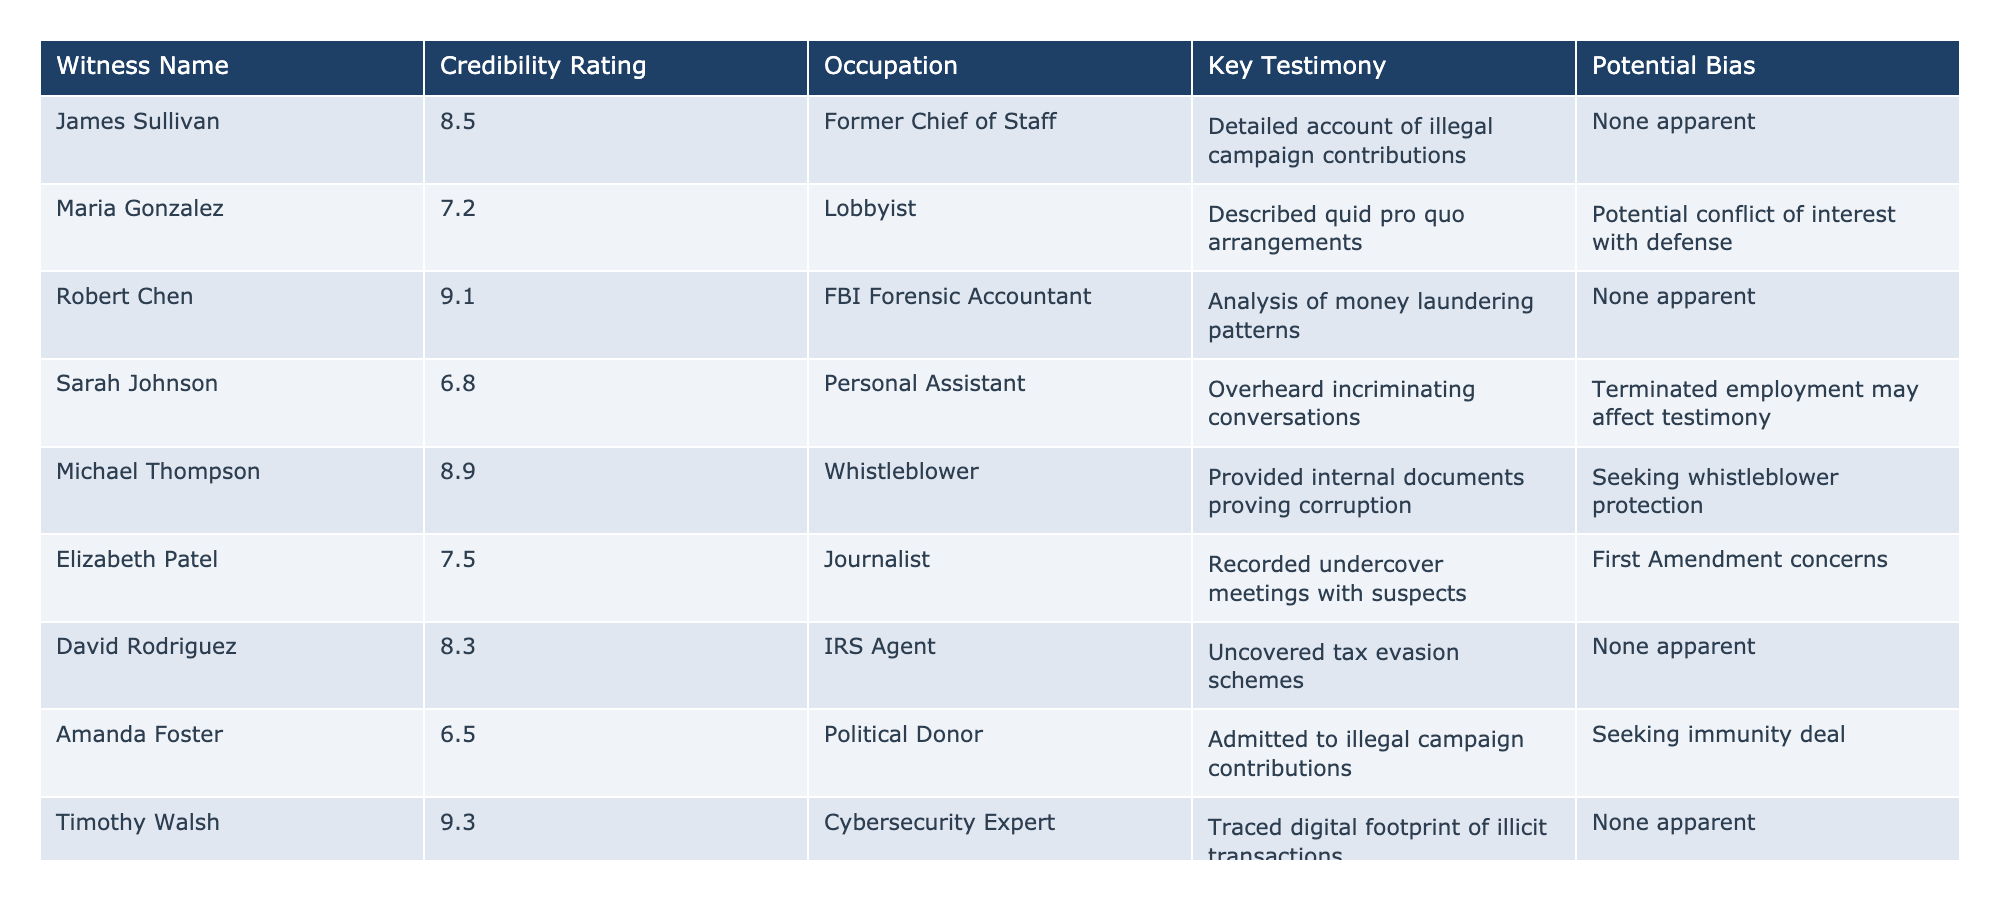What is the credibility rating of Timothy Walsh? Timothy Walsh's credibility rating is stated directly in the table as 9.3.
Answer: 9.3 Who is the witness with the highest credibility rating? By reviewing the table, Robert Chen has the highest credibility rating of 9.1.
Answer: Robert Chen Are there any witnesses with a credibility rating below 7? Looking at the table, Amanda Foster shows a credibility rating of 6.5, which is below 7.
Answer: Yes List all the witnesses who have potential bias. From the table, Maria Gonzalez, Sarah Johnson, and Karen Lewis are noted as having potential bias.
Answer: Maria Gonzalez, Sarah Johnson, Karen Lewis What is the average credibility rating of the witnesses? Adding up all the credibility ratings: 8.5 + 7.2 + 9.1 + 6.8 + 8.9 + 7.5 + 8.3 + 6.5 + 9.3 + 7.8 = 79.4, then dividing by the number of witnesses (10) gives us an average of 79.4/10 = 7.94.
Answer: 7.94 Is there a witness who is both a whistleblower and has a high credibility rating? Reviewing the table, Michael Thompson is noted as a whistleblower and has a credibility rating of 8.9, which is high.
Answer: Yes Which witness has the occupation of Journalist and what is their credibility rating? According to the table, Elizabeth Patel has the occupation of Journalist and her credibility rating is 7.5.
Answer: Elizabeth Patel, 7.5 Compare the credibility rating of James Sullivan and Amanda Foster. James Sullivan has a credibility rating of 8.5 while Amanda Foster's rating is 6.5. The difference is 8.5 - 6.5 = 2.
Answer: 2 How many witnesses have a credibility rating of 8 or higher? By checking the table, the witnesses with ratings 8 or higher are James Sullivan, Robert Chen, Michael Thompson, David Rodriguez, and Timothy Walsh. There are 5 witnesses.
Answer: 5 What notable testimony did Sarah Johnson provide? The table indicates that Sarah Johnson overheard incriminating conversations, which is her key testimony.
Answer: She overheard incriminating conversations Is there a witness who is a personal assistant and what is their credibility rating? The table lists Sarah Johnson as a personal assistant with a credibility rating of 6.8.
Answer: Yes, 6.8 